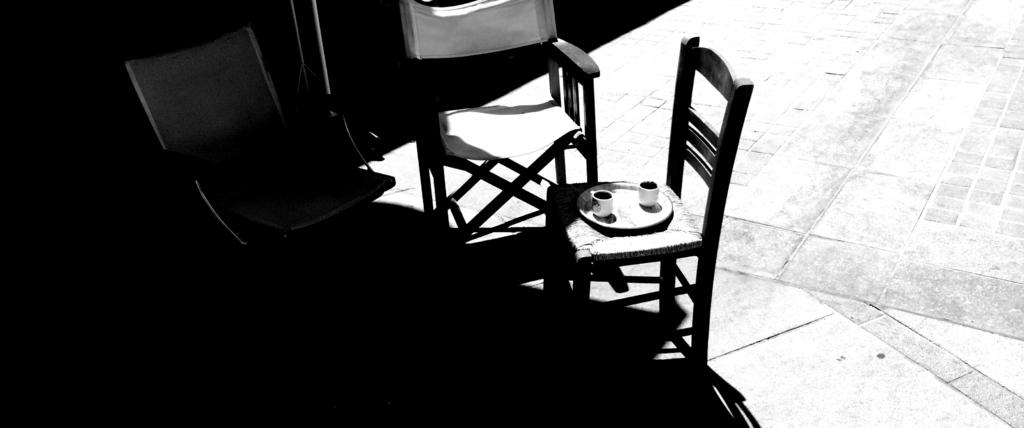What is the color scheme of the image? The image is black and white. How many chairs are visible in the image? There are three chairs in the image. What is on the plate in the image? There is a plate with two cups on it. What part of the room can be seen at the bottom of the image? The floor is visible at the bottom of the image. What type of toothbrush is shown being used in the image? There is no toothbrush present in the image. What is the name of the town where the scene in the image takes place? The image does not provide any information about the location or town where the scene takes place. 